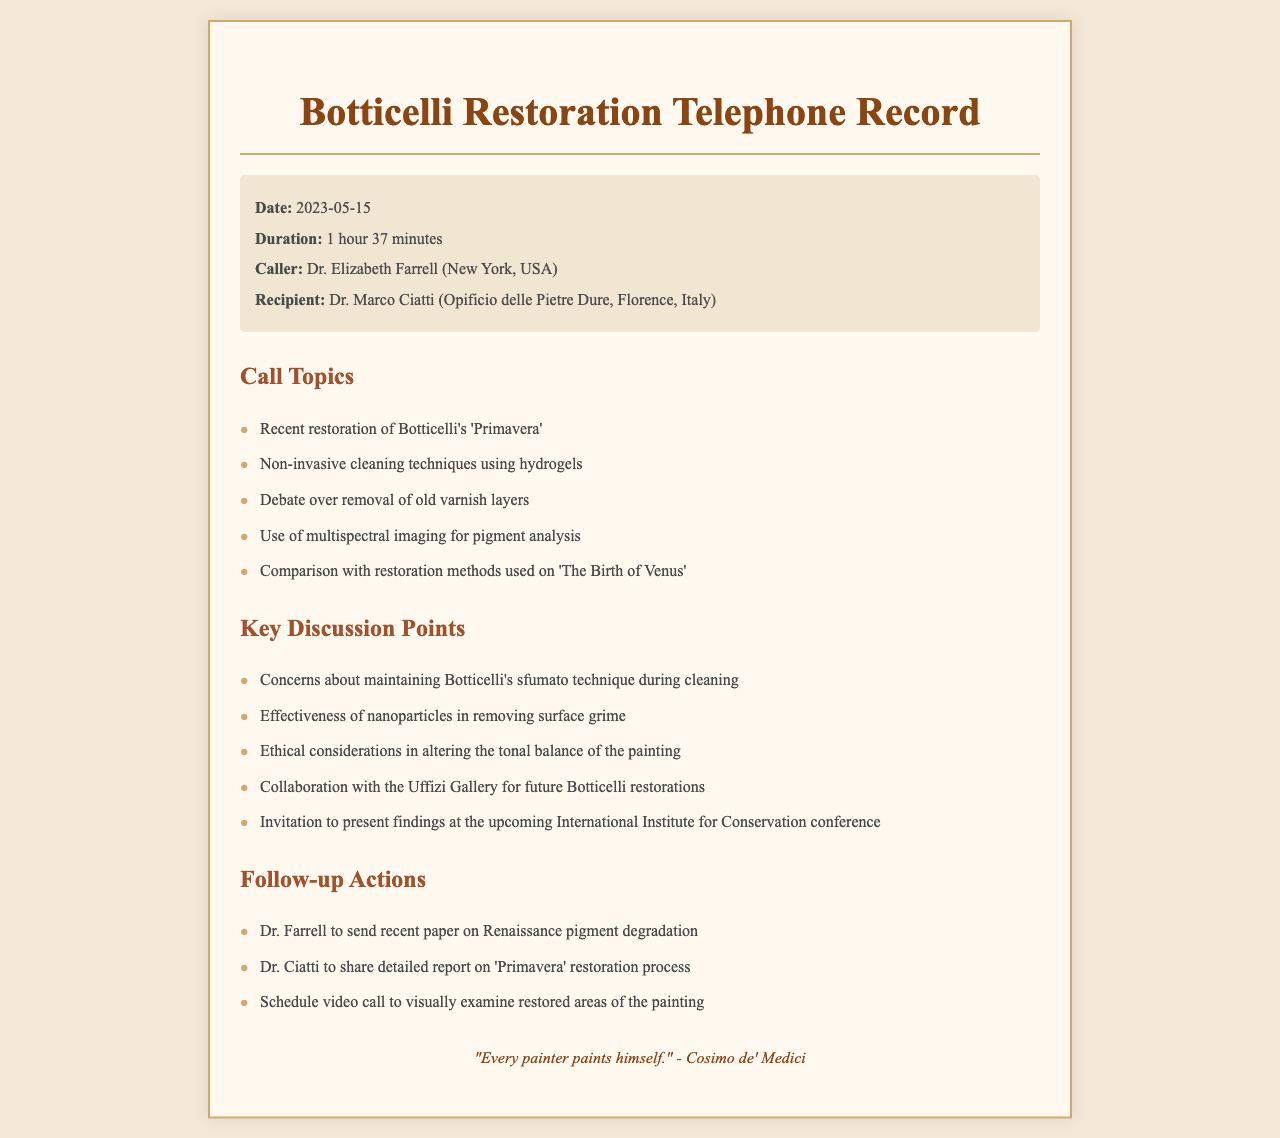What is the date of the call? The date of the call is specified in the document under the call details.
Answer: 2023-05-15 Who was the caller? The caller's name is provided in the call details section of the document.
Answer: Dr. Elizabeth Farrell How long did the call last? The duration of the call is mentioned in the call details section.
Answer: 1 hour 37 minutes Which painting's restoration was discussed? The specific painting discussed in the call is listed in the call topics section.
Answer: 'Primavera' What technique was debated regarding varnish layers? The type of debate regarding old varnish layers can be found in the key discussion points section.
Answer: Removal What ethical consideration was mentioned during the call? The ethical consideration is noted in the key discussion points of the document.
Answer: Altering tonal balance What is one modern technique used for cleaning? The modern cleaning technique mentioned is found in the call topics section of the document.
Answer: Hydrogels What follow-up action involves a paper on pigments? The follow-up action related to the paper on pigments is detailed in the follow-up actions section.
Answer: Dr. Farrell to send What invitation was extended during the call? The invitation mentioned is found in the key discussion points of the document.
Answer: Present findings at the conference Who is Dr. Ciatti associated with? The association of Dr. Ciatti is mentioned in the document under the recipient's details.
Answer: Opificio delle Pietre Dure 